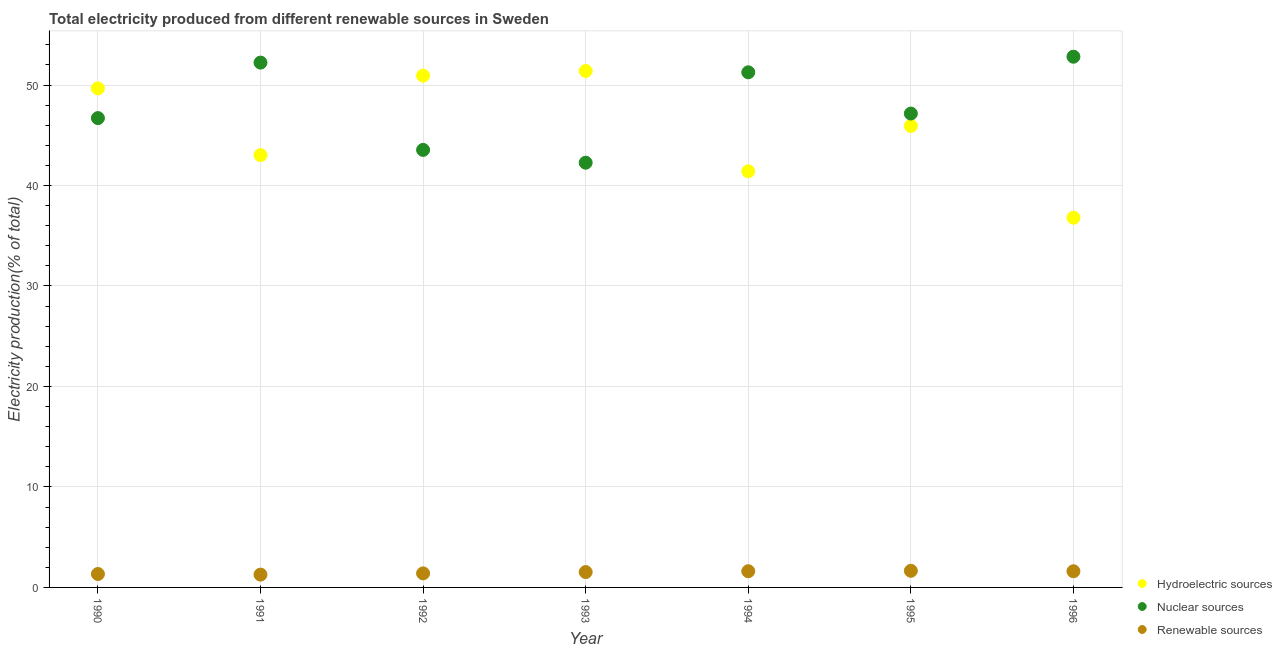What is the percentage of electricity produced by nuclear sources in 1991?
Your answer should be very brief. 52.23. Across all years, what is the maximum percentage of electricity produced by hydroelectric sources?
Make the answer very short. 51.4. Across all years, what is the minimum percentage of electricity produced by nuclear sources?
Offer a very short reply. 42.27. In which year was the percentage of electricity produced by renewable sources maximum?
Your answer should be compact. 1995. In which year was the percentage of electricity produced by hydroelectric sources minimum?
Offer a terse response. 1996. What is the total percentage of electricity produced by nuclear sources in the graph?
Provide a succinct answer. 335.99. What is the difference between the percentage of electricity produced by nuclear sources in 1991 and that in 1994?
Provide a succinct answer. 0.96. What is the difference between the percentage of electricity produced by renewable sources in 1993 and the percentage of electricity produced by nuclear sources in 1996?
Ensure brevity in your answer.  -51.29. What is the average percentage of electricity produced by hydroelectric sources per year?
Make the answer very short. 45.59. In the year 1995, what is the difference between the percentage of electricity produced by renewable sources and percentage of electricity produced by hydroelectric sources?
Ensure brevity in your answer.  -44.27. In how many years, is the percentage of electricity produced by renewable sources greater than 32 %?
Offer a terse response. 0. What is the ratio of the percentage of electricity produced by hydroelectric sources in 1991 to that in 1994?
Your answer should be compact. 1.04. Is the percentage of electricity produced by renewable sources in 1992 less than that in 1995?
Keep it short and to the point. Yes. Is the difference between the percentage of electricity produced by nuclear sources in 1991 and 1992 greater than the difference between the percentage of electricity produced by renewable sources in 1991 and 1992?
Give a very brief answer. Yes. What is the difference between the highest and the second highest percentage of electricity produced by nuclear sources?
Provide a short and direct response. 0.59. What is the difference between the highest and the lowest percentage of electricity produced by renewable sources?
Keep it short and to the point. 0.38. Is it the case that in every year, the sum of the percentage of electricity produced by hydroelectric sources and percentage of electricity produced by nuclear sources is greater than the percentage of electricity produced by renewable sources?
Your response must be concise. Yes. Is the percentage of electricity produced by renewable sources strictly greater than the percentage of electricity produced by hydroelectric sources over the years?
Provide a short and direct response. No. Is the percentage of electricity produced by renewable sources strictly less than the percentage of electricity produced by nuclear sources over the years?
Ensure brevity in your answer.  Yes. Does the graph contain grids?
Your response must be concise. Yes. How many legend labels are there?
Ensure brevity in your answer.  3. What is the title of the graph?
Your answer should be compact. Total electricity produced from different renewable sources in Sweden. Does "Male employers" appear as one of the legend labels in the graph?
Your response must be concise. No. What is the label or title of the X-axis?
Your answer should be compact. Year. What is the label or title of the Y-axis?
Provide a succinct answer. Electricity production(% of total). What is the Electricity production(% of total) in Hydroelectric sources in 1990?
Keep it short and to the point. 49.67. What is the Electricity production(% of total) of Nuclear sources in 1990?
Your response must be concise. 46.71. What is the Electricity production(% of total) of Renewable sources in 1990?
Your response must be concise. 1.34. What is the Electricity production(% of total) in Hydroelectric sources in 1991?
Offer a terse response. 43.03. What is the Electricity production(% of total) of Nuclear sources in 1991?
Your answer should be compact. 52.23. What is the Electricity production(% of total) of Renewable sources in 1991?
Your answer should be very brief. 1.27. What is the Electricity production(% of total) of Hydroelectric sources in 1992?
Offer a terse response. 50.93. What is the Electricity production(% of total) of Nuclear sources in 1992?
Offer a very short reply. 43.54. What is the Electricity production(% of total) in Renewable sources in 1992?
Provide a short and direct response. 1.4. What is the Electricity production(% of total) in Hydroelectric sources in 1993?
Make the answer very short. 51.4. What is the Electricity production(% of total) in Nuclear sources in 1993?
Your answer should be very brief. 42.27. What is the Electricity production(% of total) of Renewable sources in 1993?
Your response must be concise. 1.53. What is the Electricity production(% of total) in Hydroelectric sources in 1994?
Provide a succinct answer. 41.42. What is the Electricity production(% of total) of Nuclear sources in 1994?
Provide a succinct answer. 51.27. What is the Electricity production(% of total) in Renewable sources in 1994?
Offer a terse response. 1.61. What is the Electricity production(% of total) of Hydroelectric sources in 1995?
Provide a short and direct response. 45.92. What is the Electricity production(% of total) in Nuclear sources in 1995?
Make the answer very short. 47.16. What is the Electricity production(% of total) in Renewable sources in 1995?
Your answer should be compact. 1.65. What is the Electricity production(% of total) in Hydroelectric sources in 1996?
Ensure brevity in your answer.  36.79. What is the Electricity production(% of total) in Nuclear sources in 1996?
Give a very brief answer. 52.82. What is the Electricity production(% of total) of Renewable sources in 1996?
Offer a terse response. 1.61. Across all years, what is the maximum Electricity production(% of total) in Hydroelectric sources?
Your answer should be compact. 51.4. Across all years, what is the maximum Electricity production(% of total) in Nuclear sources?
Your answer should be compact. 52.82. Across all years, what is the maximum Electricity production(% of total) of Renewable sources?
Ensure brevity in your answer.  1.65. Across all years, what is the minimum Electricity production(% of total) of Hydroelectric sources?
Keep it short and to the point. 36.79. Across all years, what is the minimum Electricity production(% of total) of Nuclear sources?
Your answer should be compact. 42.27. Across all years, what is the minimum Electricity production(% of total) of Renewable sources?
Offer a very short reply. 1.27. What is the total Electricity production(% of total) of Hydroelectric sources in the graph?
Keep it short and to the point. 319.15. What is the total Electricity production(% of total) in Nuclear sources in the graph?
Ensure brevity in your answer.  335.99. What is the total Electricity production(% of total) in Renewable sources in the graph?
Your response must be concise. 10.41. What is the difference between the Electricity production(% of total) in Hydroelectric sources in 1990 and that in 1991?
Provide a succinct answer. 6.64. What is the difference between the Electricity production(% of total) in Nuclear sources in 1990 and that in 1991?
Provide a short and direct response. -5.52. What is the difference between the Electricity production(% of total) in Renewable sources in 1990 and that in 1991?
Your response must be concise. 0.06. What is the difference between the Electricity production(% of total) of Hydroelectric sources in 1990 and that in 1992?
Keep it short and to the point. -1.27. What is the difference between the Electricity production(% of total) of Nuclear sources in 1990 and that in 1992?
Provide a succinct answer. 3.16. What is the difference between the Electricity production(% of total) of Renewable sources in 1990 and that in 1992?
Provide a short and direct response. -0.06. What is the difference between the Electricity production(% of total) of Hydroelectric sources in 1990 and that in 1993?
Make the answer very short. -1.73. What is the difference between the Electricity production(% of total) of Nuclear sources in 1990 and that in 1993?
Offer a very short reply. 4.44. What is the difference between the Electricity production(% of total) of Renewable sources in 1990 and that in 1993?
Offer a very short reply. -0.19. What is the difference between the Electricity production(% of total) in Hydroelectric sources in 1990 and that in 1994?
Your response must be concise. 8.25. What is the difference between the Electricity production(% of total) in Nuclear sources in 1990 and that in 1994?
Offer a terse response. -4.56. What is the difference between the Electricity production(% of total) of Renewable sources in 1990 and that in 1994?
Give a very brief answer. -0.28. What is the difference between the Electricity production(% of total) in Hydroelectric sources in 1990 and that in 1995?
Make the answer very short. 3.74. What is the difference between the Electricity production(% of total) in Nuclear sources in 1990 and that in 1995?
Keep it short and to the point. -0.45. What is the difference between the Electricity production(% of total) of Renewable sources in 1990 and that in 1995?
Offer a very short reply. -0.32. What is the difference between the Electricity production(% of total) of Hydroelectric sources in 1990 and that in 1996?
Provide a succinct answer. 12.87. What is the difference between the Electricity production(% of total) in Nuclear sources in 1990 and that in 1996?
Provide a succinct answer. -6.11. What is the difference between the Electricity production(% of total) of Renewable sources in 1990 and that in 1996?
Give a very brief answer. -0.27. What is the difference between the Electricity production(% of total) in Hydroelectric sources in 1991 and that in 1992?
Provide a short and direct response. -7.91. What is the difference between the Electricity production(% of total) in Nuclear sources in 1991 and that in 1992?
Your answer should be very brief. 8.69. What is the difference between the Electricity production(% of total) of Renewable sources in 1991 and that in 1992?
Provide a short and direct response. -0.12. What is the difference between the Electricity production(% of total) of Hydroelectric sources in 1991 and that in 1993?
Your response must be concise. -8.37. What is the difference between the Electricity production(% of total) in Nuclear sources in 1991 and that in 1993?
Offer a terse response. 9.96. What is the difference between the Electricity production(% of total) in Renewable sources in 1991 and that in 1993?
Offer a very short reply. -0.25. What is the difference between the Electricity production(% of total) of Hydroelectric sources in 1991 and that in 1994?
Provide a short and direct response. 1.61. What is the difference between the Electricity production(% of total) of Nuclear sources in 1991 and that in 1994?
Make the answer very short. 0.96. What is the difference between the Electricity production(% of total) of Renewable sources in 1991 and that in 1994?
Your response must be concise. -0.34. What is the difference between the Electricity production(% of total) of Hydroelectric sources in 1991 and that in 1995?
Your answer should be compact. -2.9. What is the difference between the Electricity production(% of total) of Nuclear sources in 1991 and that in 1995?
Ensure brevity in your answer.  5.07. What is the difference between the Electricity production(% of total) of Renewable sources in 1991 and that in 1995?
Offer a very short reply. -0.38. What is the difference between the Electricity production(% of total) of Hydroelectric sources in 1991 and that in 1996?
Ensure brevity in your answer.  6.23. What is the difference between the Electricity production(% of total) of Nuclear sources in 1991 and that in 1996?
Ensure brevity in your answer.  -0.59. What is the difference between the Electricity production(% of total) of Renewable sources in 1991 and that in 1996?
Make the answer very short. -0.33. What is the difference between the Electricity production(% of total) in Hydroelectric sources in 1992 and that in 1993?
Your answer should be very brief. -0.46. What is the difference between the Electricity production(% of total) in Nuclear sources in 1992 and that in 1993?
Ensure brevity in your answer.  1.27. What is the difference between the Electricity production(% of total) of Renewable sources in 1992 and that in 1993?
Your answer should be compact. -0.13. What is the difference between the Electricity production(% of total) in Hydroelectric sources in 1992 and that in 1994?
Provide a short and direct response. 9.52. What is the difference between the Electricity production(% of total) of Nuclear sources in 1992 and that in 1994?
Offer a terse response. -7.72. What is the difference between the Electricity production(% of total) of Renewable sources in 1992 and that in 1994?
Your response must be concise. -0.21. What is the difference between the Electricity production(% of total) in Hydroelectric sources in 1992 and that in 1995?
Offer a very short reply. 5.01. What is the difference between the Electricity production(% of total) of Nuclear sources in 1992 and that in 1995?
Offer a very short reply. -3.62. What is the difference between the Electricity production(% of total) in Renewable sources in 1992 and that in 1995?
Provide a succinct answer. -0.26. What is the difference between the Electricity production(% of total) of Hydroelectric sources in 1992 and that in 1996?
Give a very brief answer. 14.14. What is the difference between the Electricity production(% of total) of Nuclear sources in 1992 and that in 1996?
Offer a very short reply. -9.27. What is the difference between the Electricity production(% of total) of Renewable sources in 1992 and that in 1996?
Provide a short and direct response. -0.21. What is the difference between the Electricity production(% of total) of Hydroelectric sources in 1993 and that in 1994?
Give a very brief answer. 9.98. What is the difference between the Electricity production(% of total) in Nuclear sources in 1993 and that in 1994?
Make the answer very short. -9. What is the difference between the Electricity production(% of total) in Renewable sources in 1993 and that in 1994?
Provide a succinct answer. -0.08. What is the difference between the Electricity production(% of total) in Hydroelectric sources in 1993 and that in 1995?
Provide a short and direct response. 5.47. What is the difference between the Electricity production(% of total) in Nuclear sources in 1993 and that in 1995?
Provide a succinct answer. -4.89. What is the difference between the Electricity production(% of total) in Renewable sources in 1993 and that in 1995?
Give a very brief answer. -0.13. What is the difference between the Electricity production(% of total) of Hydroelectric sources in 1993 and that in 1996?
Your answer should be very brief. 14.6. What is the difference between the Electricity production(% of total) of Nuclear sources in 1993 and that in 1996?
Provide a short and direct response. -10.55. What is the difference between the Electricity production(% of total) of Renewable sources in 1993 and that in 1996?
Provide a short and direct response. -0.08. What is the difference between the Electricity production(% of total) in Hydroelectric sources in 1994 and that in 1995?
Keep it short and to the point. -4.51. What is the difference between the Electricity production(% of total) of Nuclear sources in 1994 and that in 1995?
Provide a short and direct response. 4.11. What is the difference between the Electricity production(% of total) of Renewable sources in 1994 and that in 1995?
Ensure brevity in your answer.  -0.04. What is the difference between the Electricity production(% of total) in Hydroelectric sources in 1994 and that in 1996?
Your answer should be very brief. 4.62. What is the difference between the Electricity production(% of total) in Nuclear sources in 1994 and that in 1996?
Your response must be concise. -1.55. What is the difference between the Electricity production(% of total) of Renewable sources in 1994 and that in 1996?
Offer a terse response. 0. What is the difference between the Electricity production(% of total) of Hydroelectric sources in 1995 and that in 1996?
Give a very brief answer. 9.13. What is the difference between the Electricity production(% of total) of Nuclear sources in 1995 and that in 1996?
Your answer should be very brief. -5.66. What is the difference between the Electricity production(% of total) of Renewable sources in 1995 and that in 1996?
Ensure brevity in your answer.  0.05. What is the difference between the Electricity production(% of total) in Hydroelectric sources in 1990 and the Electricity production(% of total) in Nuclear sources in 1991?
Give a very brief answer. -2.56. What is the difference between the Electricity production(% of total) in Hydroelectric sources in 1990 and the Electricity production(% of total) in Renewable sources in 1991?
Make the answer very short. 48.39. What is the difference between the Electricity production(% of total) in Nuclear sources in 1990 and the Electricity production(% of total) in Renewable sources in 1991?
Keep it short and to the point. 45.43. What is the difference between the Electricity production(% of total) of Hydroelectric sources in 1990 and the Electricity production(% of total) of Nuclear sources in 1992?
Your answer should be compact. 6.12. What is the difference between the Electricity production(% of total) in Hydroelectric sources in 1990 and the Electricity production(% of total) in Renewable sources in 1992?
Offer a terse response. 48.27. What is the difference between the Electricity production(% of total) in Nuclear sources in 1990 and the Electricity production(% of total) in Renewable sources in 1992?
Offer a terse response. 45.31. What is the difference between the Electricity production(% of total) of Hydroelectric sources in 1990 and the Electricity production(% of total) of Nuclear sources in 1993?
Your answer should be compact. 7.4. What is the difference between the Electricity production(% of total) of Hydroelectric sources in 1990 and the Electricity production(% of total) of Renewable sources in 1993?
Keep it short and to the point. 48.14. What is the difference between the Electricity production(% of total) in Nuclear sources in 1990 and the Electricity production(% of total) in Renewable sources in 1993?
Give a very brief answer. 45.18. What is the difference between the Electricity production(% of total) of Hydroelectric sources in 1990 and the Electricity production(% of total) of Nuclear sources in 1994?
Your response must be concise. -1.6. What is the difference between the Electricity production(% of total) in Hydroelectric sources in 1990 and the Electricity production(% of total) in Renewable sources in 1994?
Your answer should be compact. 48.05. What is the difference between the Electricity production(% of total) in Nuclear sources in 1990 and the Electricity production(% of total) in Renewable sources in 1994?
Your answer should be compact. 45.09. What is the difference between the Electricity production(% of total) in Hydroelectric sources in 1990 and the Electricity production(% of total) in Nuclear sources in 1995?
Your answer should be compact. 2.5. What is the difference between the Electricity production(% of total) in Hydroelectric sources in 1990 and the Electricity production(% of total) in Renewable sources in 1995?
Provide a succinct answer. 48.01. What is the difference between the Electricity production(% of total) in Nuclear sources in 1990 and the Electricity production(% of total) in Renewable sources in 1995?
Your response must be concise. 45.05. What is the difference between the Electricity production(% of total) in Hydroelectric sources in 1990 and the Electricity production(% of total) in Nuclear sources in 1996?
Your answer should be very brief. -3.15. What is the difference between the Electricity production(% of total) in Hydroelectric sources in 1990 and the Electricity production(% of total) in Renewable sources in 1996?
Provide a short and direct response. 48.06. What is the difference between the Electricity production(% of total) of Nuclear sources in 1990 and the Electricity production(% of total) of Renewable sources in 1996?
Provide a succinct answer. 45.1. What is the difference between the Electricity production(% of total) of Hydroelectric sources in 1991 and the Electricity production(% of total) of Nuclear sources in 1992?
Ensure brevity in your answer.  -0.52. What is the difference between the Electricity production(% of total) of Hydroelectric sources in 1991 and the Electricity production(% of total) of Renewable sources in 1992?
Offer a very short reply. 41.63. What is the difference between the Electricity production(% of total) of Nuclear sources in 1991 and the Electricity production(% of total) of Renewable sources in 1992?
Provide a succinct answer. 50.83. What is the difference between the Electricity production(% of total) in Hydroelectric sources in 1991 and the Electricity production(% of total) in Nuclear sources in 1993?
Ensure brevity in your answer.  0.76. What is the difference between the Electricity production(% of total) in Hydroelectric sources in 1991 and the Electricity production(% of total) in Renewable sources in 1993?
Provide a succinct answer. 41.5. What is the difference between the Electricity production(% of total) in Nuclear sources in 1991 and the Electricity production(% of total) in Renewable sources in 1993?
Make the answer very short. 50.7. What is the difference between the Electricity production(% of total) in Hydroelectric sources in 1991 and the Electricity production(% of total) in Nuclear sources in 1994?
Give a very brief answer. -8.24. What is the difference between the Electricity production(% of total) in Hydroelectric sources in 1991 and the Electricity production(% of total) in Renewable sources in 1994?
Give a very brief answer. 41.41. What is the difference between the Electricity production(% of total) of Nuclear sources in 1991 and the Electricity production(% of total) of Renewable sources in 1994?
Keep it short and to the point. 50.62. What is the difference between the Electricity production(% of total) of Hydroelectric sources in 1991 and the Electricity production(% of total) of Nuclear sources in 1995?
Make the answer very short. -4.13. What is the difference between the Electricity production(% of total) of Hydroelectric sources in 1991 and the Electricity production(% of total) of Renewable sources in 1995?
Ensure brevity in your answer.  41.37. What is the difference between the Electricity production(% of total) of Nuclear sources in 1991 and the Electricity production(% of total) of Renewable sources in 1995?
Ensure brevity in your answer.  50.57. What is the difference between the Electricity production(% of total) of Hydroelectric sources in 1991 and the Electricity production(% of total) of Nuclear sources in 1996?
Offer a terse response. -9.79. What is the difference between the Electricity production(% of total) of Hydroelectric sources in 1991 and the Electricity production(% of total) of Renewable sources in 1996?
Your answer should be very brief. 41.42. What is the difference between the Electricity production(% of total) of Nuclear sources in 1991 and the Electricity production(% of total) of Renewable sources in 1996?
Give a very brief answer. 50.62. What is the difference between the Electricity production(% of total) of Hydroelectric sources in 1992 and the Electricity production(% of total) of Nuclear sources in 1993?
Ensure brevity in your answer.  8.67. What is the difference between the Electricity production(% of total) in Hydroelectric sources in 1992 and the Electricity production(% of total) in Renewable sources in 1993?
Provide a short and direct response. 49.41. What is the difference between the Electricity production(% of total) in Nuclear sources in 1992 and the Electricity production(% of total) in Renewable sources in 1993?
Your response must be concise. 42.01. What is the difference between the Electricity production(% of total) of Hydroelectric sources in 1992 and the Electricity production(% of total) of Nuclear sources in 1994?
Your answer should be compact. -0.33. What is the difference between the Electricity production(% of total) in Hydroelectric sources in 1992 and the Electricity production(% of total) in Renewable sources in 1994?
Your response must be concise. 49.32. What is the difference between the Electricity production(% of total) of Nuclear sources in 1992 and the Electricity production(% of total) of Renewable sources in 1994?
Keep it short and to the point. 41.93. What is the difference between the Electricity production(% of total) of Hydroelectric sources in 1992 and the Electricity production(% of total) of Nuclear sources in 1995?
Provide a succinct answer. 3.77. What is the difference between the Electricity production(% of total) of Hydroelectric sources in 1992 and the Electricity production(% of total) of Renewable sources in 1995?
Offer a very short reply. 49.28. What is the difference between the Electricity production(% of total) of Nuclear sources in 1992 and the Electricity production(% of total) of Renewable sources in 1995?
Provide a short and direct response. 41.89. What is the difference between the Electricity production(% of total) in Hydroelectric sources in 1992 and the Electricity production(% of total) in Nuclear sources in 1996?
Keep it short and to the point. -1.88. What is the difference between the Electricity production(% of total) in Hydroelectric sources in 1992 and the Electricity production(% of total) in Renewable sources in 1996?
Offer a very short reply. 49.33. What is the difference between the Electricity production(% of total) in Nuclear sources in 1992 and the Electricity production(% of total) in Renewable sources in 1996?
Your answer should be compact. 41.93. What is the difference between the Electricity production(% of total) of Hydroelectric sources in 1993 and the Electricity production(% of total) of Nuclear sources in 1994?
Keep it short and to the point. 0.13. What is the difference between the Electricity production(% of total) of Hydroelectric sources in 1993 and the Electricity production(% of total) of Renewable sources in 1994?
Make the answer very short. 49.78. What is the difference between the Electricity production(% of total) in Nuclear sources in 1993 and the Electricity production(% of total) in Renewable sources in 1994?
Make the answer very short. 40.66. What is the difference between the Electricity production(% of total) in Hydroelectric sources in 1993 and the Electricity production(% of total) in Nuclear sources in 1995?
Keep it short and to the point. 4.24. What is the difference between the Electricity production(% of total) of Hydroelectric sources in 1993 and the Electricity production(% of total) of Renewable sources in 1995?
Give a very brief answer. 49.74. What is the difference between the Electricity production(% of total) in Nuclear sources in 1993 and the Electricity production(% of total) in Renewable sources in 1995?
Offer a very short reply. 40.61. What is the difference between the Electricity production(% of total) in Hydroelectric sources in 1993 and the Electricity production(% of total) in Nuclear sources in 1996?
Ensure brevity in your answer.  -1.42. What is the difference between the Electricity production(% of total) in Hydroelectric sources in 1993 and the Electricity production(% of total) in Renewable sources in 1996?
Ensure brevity in your answer.  49.79. What is the difference between the Electricity production(% of total) in Nuclear sources in 1993 and the Electricity production(% of total) in Renewable sources in 1996?
Your answer should be very brief. 40.66. What is the difference between the Electricity production(% of total) of Hydroelectric sources in 1994 and the Electricity production(% of total) of Nuclear sources in 1995?
Your answer should be compact. -5.74. What is the difference between the Electricity production(% of total) in Hydroelectric sources in 1994 and the Electricity production(% of total) in Renewable sources in 1995?
Ensure brevity in your answer.  39.76. What is the difference between the Electricity production(% of total) in Nuclear sources in 1994 and the Electricity production(% of total) in Renewable sources in 1995?
Your answer should be compact. 49.61. What is the difference between the Electricity production(% of total) of Hydroelectric sources in 1994 and the Electricity production(% of total) of Nuclear sources in 1996?
Offer a terse response. -11.4. What is the difference between the Electricity production(% of total) in Hydroelectric sources in 1994 and the Electricity production(% of total) in Renewable sources in 1996?
Provide a short and direct response. 39.81. What is the difference between the Electricity production(% of total) in Nuclear sources in 1994 and the Electricity production(% of total) in Renewable sources in 1996?
Your answer should be compact. 49.66. What is the difference between the Electricity production(% of total) in Hydroelectric sources in 1995 and the Electricity production(% of total) in Nuclear sources in 1996?
Your response must be concise. -6.89. What is the difference between the Electricity production(% of total) in Hydroelectric sources in 1995 and the Electricity production(% of total) in Renewable sources in 1996?
Keep it short and to the point. 44.31. What is the difference between the Electricity production(% of total) in Nuclear sources in 1995 and the Electricity production(% of total) in Renewable sources in 1996?
Provide a succinct answer. 45.55. What is the average Electricity production(% of total) in Hydroelectric sources per year?
Ensure brevity in your answer.  45.59. What is the average Electricity production(% of total) of Nuclear sources per year?
Offer a very short reply. 48. What is the average Electricity production(% of total) of Renewable sources per year?
Your response must be concise. 1.49. In the year 1990, what is the difference between the Electricity production(% of total) in Hydroelectric sources and Electricity production(% of total) in Nuclear sources?
Offer a terse response. 2.96. In the year 1990, what is the difference between the Electricity production(% of total) of Hydroelectric sources and Electricity production(% of total) of Renewable sources?
Your answer should be very brief. 48.33. In the year 1990, what is the difference between the Electricity production(% of total) of Nuclear sources and Electricity production(% of total) of Renewable sources?
Your answer should be very brief. 45.37. In the year 1991, what is the difference between the Electricity production(% of total) of Hydroelectric sources and Electricity production(% of total) of Nuclear sources?
Your response must be concise. -9.2. In the year 1991, what is the difference between the Electricity production(% of total) of Hydroelectric sources and Electricity production(% of total) of Renewable sources?
Offer a terse response. 41.75. In the year 1991, what is the difference between the Electricity production(% of total) in Nuclear sources and Electricity production(% of total) in Renewable sources?
Make the answer very short. 50.95. In the year 1992, what is the difference between the Electricity production(% of total) of Hydroelectric sources and Electricity production(% of total) of Nuclear sources?
Provide a short and direct response. 7.39. In the year 1992, what is the difference between the Electricity production(% of total) in Hydroelectric sources and Electricity production(% of total) in Renewable sources?
Give a very brief answer. 49.54. In the year 1992, what is the difference between the Electricity production(% of total) of Nuclear sources and Electricity production(% of total) of Renewable sources?
Ensure brevity in your answer.  42.14. In the year 1993, what is the difference between the Electricity production(% of total) of Hydroelectric sources and Electricity production(% of total) of Nuclear sources?
Give a very brief answer. 9.13. In the year 1993, what is the difference between the Electricity production(% of total) of Hydroelectric sources and Electricity production(% of total) of Renewable sources?
Offer a very short reply. 49.87. In the year 1993, what is the difference between the Electricity production(% of total) in Nuclear sources and Electricity production(% of total) in Renewable sources?
Provide a succinct answer. 40.74. In the year 1994, what is the difference between the Electricity production(% of total) of Hydroelectric sources and Electricity production(% of total) of Nuclear sources?
Your answer should be very brief. -9.85. In the year 1994, what is the difference between the Electricity production(% of total) in Hydroelectric sources and Electricity production(% of total) in Renewable sources?
Offer a very short reply. 39.8. In the year 1994, what is the difference between the Electricity production(% of total) in Nuclear sources and Electricity production(% of total) in Renewable sources?
Keep it short and to the point. 49.65. In the year 1995, what is the difference between the Electricity production(% of total) of Hydroelectric sources and Electricity production(% of total) of Nuclear sources?
Keep it short and to the point. -1.24. In the year 1995, what is the difference between the Electricity production(% of total) of Hydroelectric sources and Electricity production(% of total) of Renewable sources?
Provide a short and direct response. 44.27. In the year 1995, what is the difference between the Electricity production(% of total) of Nuclear sources and Electricity production(% of total) of Renewable sources?
Offer a very short reply. 45.51. In the year 1996, what is the difference between the Electricity production(% of total) in Hydroelectric sources and Electricity production(% of total) in Nuclear sources?
Provide a short and direct response. -16.02. In the year 1996, what is the difference between the Electricity production(% of total) in Hydroelectric sources and Electricity production(% of total) in Renewable sources?
Your answer should be very brief. 35.18. In the year 1996, what is the difference between the Electricity production(% of total) of Nuclear sources and Electricity production(% of total) of Renewable sources?
Give a very brief answer. 51.21. What is the ratio of the Electricity production(% of total) of Hydroelectric sources in 1990 to that in 1991?
Give a very brief answer. 1.15. What is the ratio of the Electricity production(% of total) in Nuclear sources in 1990 to that in 1991?
Your response must be concise. 0.89. What is the ratio of the Electricity production(% of total) in Renewable sources in 1990 to that in 1991?
Your answer should be compact. 1.05. What is the ratio of the Electricity production(% of total) in Hydroelectric sources in 1990 to that in 1992?
Keep it short and to the point. 0.98. What is the ratio of the Electricity production(% of total) of Nuclear sources in 1990 to that in 1992?
Offer a terse response. 1.07. What is the ratio of the Electricity production(% of total) of Renewable sources in 1990 to that in 1992?
Make the answer very short. 0.95. What is the ratio of the Electricity production(% of total) in Hydroelectric sources in 1990 to that in 1993?
Your answer should be compact. 0.97. What is the ratio of the Electricity production(% of total) of Nuclear sources in 1990 to that in 1993?
Provide a short and direct response. 1.1. What is the ratio of the Electricity production(% of total) in Renewable sources in 1990 to that in 1993?
Offer a terse response. 0.87. What is the ratio of the Electricity production(% of total) in Hydroelectric sources in 1990 to that in 1994?
Your answer should be very brief. 1.2. What is the ratio of the Electricity production(% of total) of Nuclear sources in 1990 to that in 1994?
Offer a very short reply. 0.91. What is the ratio of the Electricity production(% of total) of Renewable sources in 1990 to that in 1994?
Offer a very short reply. 0.83. What is the ratio of the Electricity production(% of total) in Hydroelectric sources in 1990 to that in 1995?
Make the answer very short. 1.08. What is the ratio of the Electricity production(% of total) of Nuclear sources in 1990 to that in 1995?
Provide a short and direct response. 0.99. What is the ratio of the Electricity production(% of total) in Renewable sources in 1990 to that in 1995?
Your answer should be very brief. 0.81. What is the ratio of the Electricity production(% of total) in Hydroelectric sources in 1990 to that in 1996?
Provide a succinct answer. 1.35. What is the ratio of the Electricity production(% of total) of Nuclear sources in 1990 to that in 1996?
Ensure brevity in your answer.  0.88. What is the ratio of the Electricity production(% of total) in Renewable sources in 1990 to that in 1996?
Your response must be concise. 0.83. What is the ratio of the Electricity production(% of total) in Hydroelectric sources in 1991 to that in 1992?
Provide a succinct answer. 0.84. What is the ratio of the Electricity production(% of total) in Nuclear sources in 1991 to that in 1992?
Offer a very short reply. 1.2. What is the ratio of the Electricity production(% of total) of Renewable sources in 1991 to that in 1992?
Your answer should be very brief. 0.91. What is the ratio of the Electricity production(% of total) of Hydroelectric sources in 1991 to that in 1993?
Make the answer very short. 0.84. What is the ratio of the Electricity production(% of total) in Nuclear sources in 1991 to that in 1993?
Make the answer very short. 1.24. What is the ratio of the Electricity production(% of total) in Renewable sources in 1991 to that in 1993?
Provide a short and direct response. 0.83. What is the ratio of the Electricity production(% of total) of Hydroelectric sources in 1991 to that in 1994?
Provide a succinct answer. 1.04. What is the ratio of the Electricity production(% of total) of Nuclear sources in 1991 to that in 1994?
Provide a succinct answer. 1.02. What is the ratio of the Electricity production(% of total) in Renewable sources in 1991 to that in 1994?
Offer a very short reply. 0.79. What is the ratio of the Electricity production(% of total) of Hydroelectric sources in 1991 to that in 1995?
Provide a short and direct response. 0.94. What is the ratio of the Electricity production(% of total) of Nuclear sources in 1991 to that in 1995?
Keep it short and to the point. 1.11. What is the ratio of the Electricity production(% of total) of Renewable sources in 1991 to that in 1995?
Provide a short and direct response. 0.77. What is the ratio of the Electricity production(% of total) in Hydroelectric sources in 1991 to that in 1996?
Your answer should be compact. 1.17. What is the ratio of the Electricity production(% of total) in Nuclear sources in 1991 to that in 1996?
Give a very brief answer. 0.99. What is the ratio of the Electricity production(% of total) of Renewable sources in 1991 to that in 1996?
Provide a short and direct response. 0.79. What is the ratio of the Electricity production(% of total) in Hydroelectric sources in 1992 to that in 1993?
Provide a short and direct response. 0.99. What is the ratio of the Electricity production(% of total) in Nuclear sources in 1992 to that in 1993?
Your answer should be very brief. 1.03. What is the ratio of the Electricity production(% of total) in Renewable sources in 1992 to that in 1993?
Your answer should be very brief. 0.92. What is the ratio of the Electricity production(% of total) of Hydroelectric sources in 1992 to that in 1994?
Provide a short and direct response. 1.23. What is the ratio of the Electricity production(% of total) of Nuclear sources in 1992 to that in 1994?
Offer a terse response. 0.85. What is the ratio of the Electricity production(% of total) of Renewable sources in 1992 to that in 1994?
Make the answer very short. 0.87. What is the ratio of the Electricity production(% of total) in Hydroelectric sources in 1992 to that in 1995?
Offer a very short reply. 1.11. What is the ratio of the Electricity production(% of total) in Nuclear sources in 1992 to that in 1995?
Ensure brevity in your answer.  0.92. What is the ratio of the Electricity production(% of total) of Renewable sources in 1992 to that in 1995?
Offer a very short reply. 0.85. What is the ratio of the Electricity production(% of total) in Hydroelectric sources in 1992 to that in 1996?
Your answer should be very brief. 1.38. What is the ratio of the Electricity production(% of total) of Nuclear sources in 1992 to that in 1996?
Your response must be concise. 0.82. What is the ratio of the Electricity production(% of total) in Renewable sources in 1992 to that in 1996?
Make the answer very short. 0.87. What is the ratio of the Electricity production(% of total) of Hydroelectric sources in 1993 to that in 1994?
Ensure brevity in your answer.  1.24. What is the ratio of the Electricity production(% of total) of Nuclear sources in 1993 to that in 1994?
Your response must be concise. 0.82. What is the ratio of the Electricity production(% of total) of Renewable sources in 1993 to that in 1994?
Provide a short and direct response. 0.95. What is the ratio of the Electricity production(% of total) of Hydroelectric sources in 1993 to that in 1995?
Your answer should be compact. 1.12. What is the ratio of the Electricity production(% of total) of Nuclear sources in 1993 to that in 1995?
Your answer should be very brief. 0.9. What is the ratio of the Electricity production(% of total) in Renewable sources in 1993 to that in 1995?
Keep it short and to the point. 0.92. What is the ratio of the Electricity production(% of total) of Hydroelectric sources in 1993 to that in 1996?
Offer a terse response. 1.4. What is the ratio of the Electricity production(% of total) in Nuclear sources in 1993 to that in 1996?
Give a very brief answer. 0.8. What is the ratio of the Electricity production(% of total) of Renewable sources in 1993 to that in 1996?
Your response must be concise. 0.95. What is the ratio of the Electricity production(% of total) in Hydroelectric sources in 1994 to that in 1995?
Provide a short and direct response. 0.9. What is the ratio of the Electricity production(% of total) in Nuclear sources in 1994 to that in 1995?
Your answer should be compact. 1.09. What is the ratio of the Electricity production(% of total) of Renewable sources in 1994 to that in 1995?
Ensure brevity in your answer.  0.97. What is the ratio of the Electricity production(% of total) in Hydroelectric sources in 1994 to that in 1996?
Provide a succinct answer. 1.13. What is the ratio of the Electricity production(% of total) in Nuclear sources in 1994 to that in 1996?
Your answer should be compact. 0.97. What is the ratio of the Electricity production(% of total) in Hydroelectric sources in 1995 to that in 1996?
Provide a short and direct response. 1.25. What is the ratio of the Electricity production(% of total) of Nuclear sources in 1995 to that in 1996?
Make the answer very short. 0.89. What is the ratio of the Electricity production(% of total) in Renewable sources in 1995 to that in 1996?
Your answer should be very brief. 1.03. What is the difference between the highest and the second highest Electricity production(% of total) in Hydroelectric sources?
Offer a terse response. 0.46. What is the difference between the highest and the second highest Electricity production(% of total) of Nuclear sources?
Keep it short and to the point. 0.59. What is the difference between the highest and the second highest Electricity production(% of total) of Renewable sources?
Your answer should be compact. 0.04. What is the difference between the highest and the lowest Electricity production(% of total) of Hydroelectric sources?
Provide a succinct answer. 14.6. What is the difference between the highest and the lowest Electricity production(% of total) of Nuclear sources?
Your answer should be very brief. 10.55. What is the difference between the highest and the lowest Electricity production(% of total) of Renewable sources?
Make the answer very short. 0.38. 